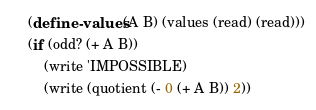Convert code to text. <code><loc_0><loc_0><loc_500><loc_500><_Scheme_>(define-values (A B) (values (read) (read)))
(if (odd? (+ A B))
    (write 'IMPOSSIBLE)
    (write (quotient (- 0 (+ A B)) 2))</code> 